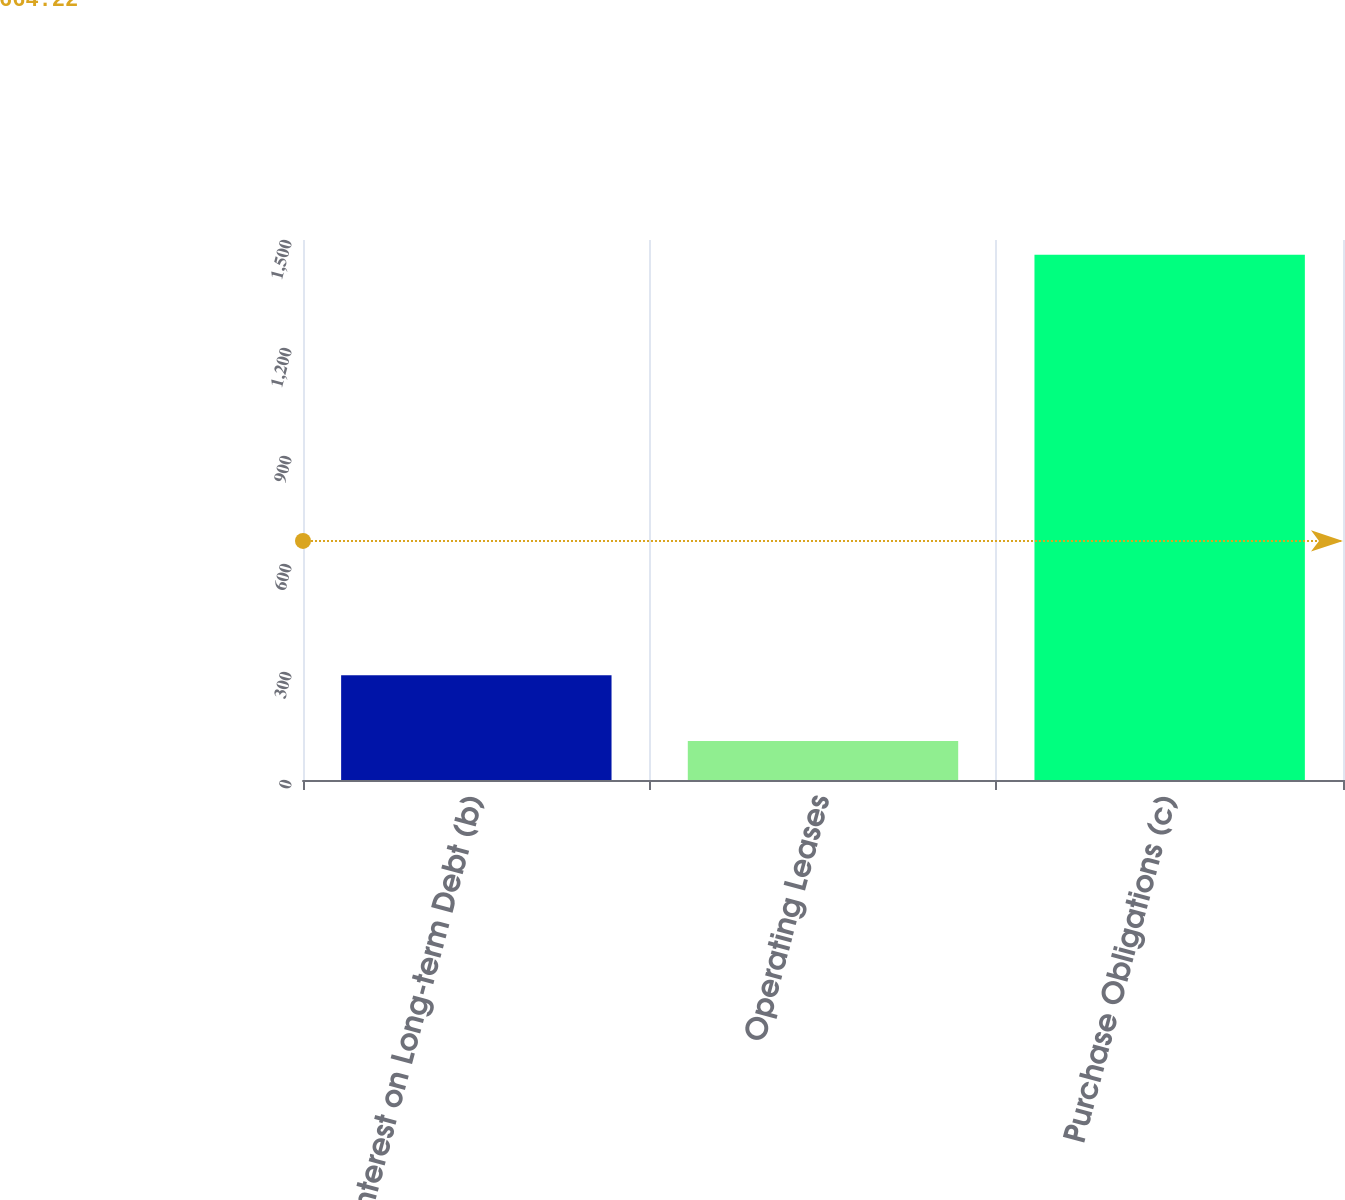<chart> <loc_0><loc_0><loc_500><loc_500><bar_chart><fcel>Interest on Long-term Debt (b)<fcel>Operating Leases<fcel>Purchase Obligations (c)<nl><fcel>291<fcel>108<fcel>1459<nl></chart> 